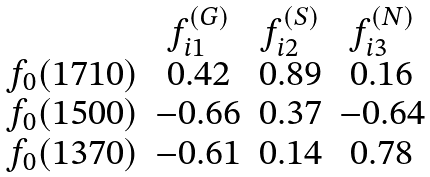Convert formula to latex. <formula><loc_0><loc_0><loc_500><loc_500>\begin{array} { c c c c } & f _ { i 1 } ^ { ( G ) } & f _ { i 2 } ^ { ( S ) } & f _ { i 3 } ^ { ( N ) } \\ f _ { 0 } ( 1 7 1 0 ) & 0 . 4 2 & 0 . 8 9 & 0 . 1 6 \\ f _ { 0 } ( 1 5 0 0 ) & - 0 . 6 6 & 0 . 3 7 & - 0 . 6 4 \\ f _ { 0 } ( 1 3 7 0 ) & - 0 . 6 1 & 0 . 1 4 & 0 . 7 8 \\ \end{array}</formula> 